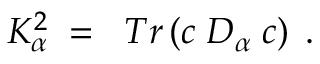<formula> <loc_0><loc_0><loc_500><loc_500>\, K _ { \alpha } ^ { 2 } \, = \, T r \left ( c \, D _ { \alpha } \, c \right ) \, .</formula> 